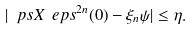Convert formula to latex. <formula><loc_0><loc_0><loc_500><loc_500>| \ p s X { \ e p s ^ { 2 n } ( 0 ) - \xi _ { n } } { \psi } | \leq \eta .</formula> 